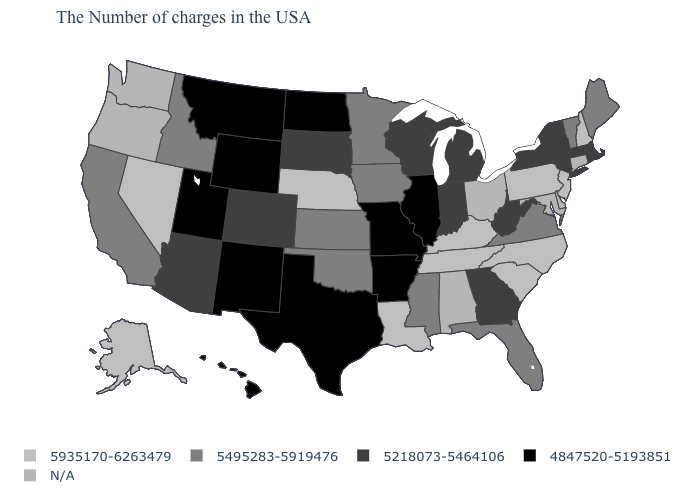What is the value of West Virginia?
Quick response, please. 5218073-5464106. Among the states that border Illinois , which have the highest value?
Quick response, please. Kentucky. Is the legend a continuous bar?
Write a very short answer. No. What is the value of Nebraska?
Short answer required. 5935170-6263479. What is the value of Colorado?
Write a very short answer. 5218073-5464106. What is the value of Georgia?
Write a very short answer. 5218073-5464106. Name the states that have a value in the range 4847520-5193851?
Give a very brief answer. Illinois, Missouri, Arkansas, Texas, North Dakota, Wyoming, New Mexico, Utah, Montana, Hawaii. Name the states that have a value in the range N/A?
Give a very brief answer. Connecticut, Delaware, Maryland, Ohio, Alabama, Washington, Oregon. Among the states that border Maryland , which have the lowest value?
Concise answer only. West Virginia. Does the map have missing data?
Concise answer only. Yes. Does Massachusetts have the lowest value in the Northeast?
Answer briefly. Yes. What is the value of Montana?
Answer briefly. 4847520-5193851. Name the states that have a value in the range N/A?
Answer briefly. Connecticut, Delaware, Maryland, Ohio, Alabama, Washington, Oregon. What is the highest value in states that border Indiana?
Answer briefly. 5935170-6263479. 